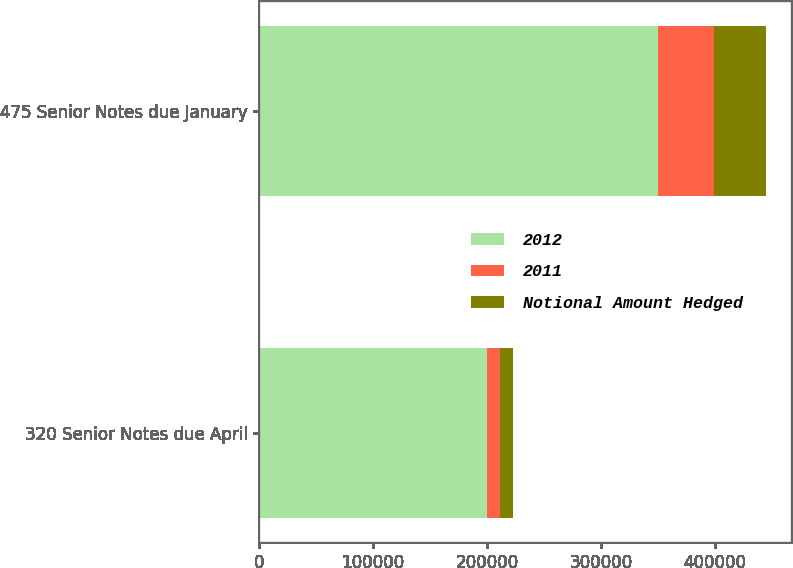Convert chart. <chart><loc_0><loc_0><loc_500><loc_500><stacked_bar_chart><ecel><fcel>320 Senior Notes due April<fcel>475 Senior Notes due January<nl><fcel>2012<fcel>200000<fcel>350000<nl><fcel>2011<fcel>11659<fcel>48912<nl><fcel>Notional Amount Hedged<fcel>10858<fcel>45662<nl></chart> 